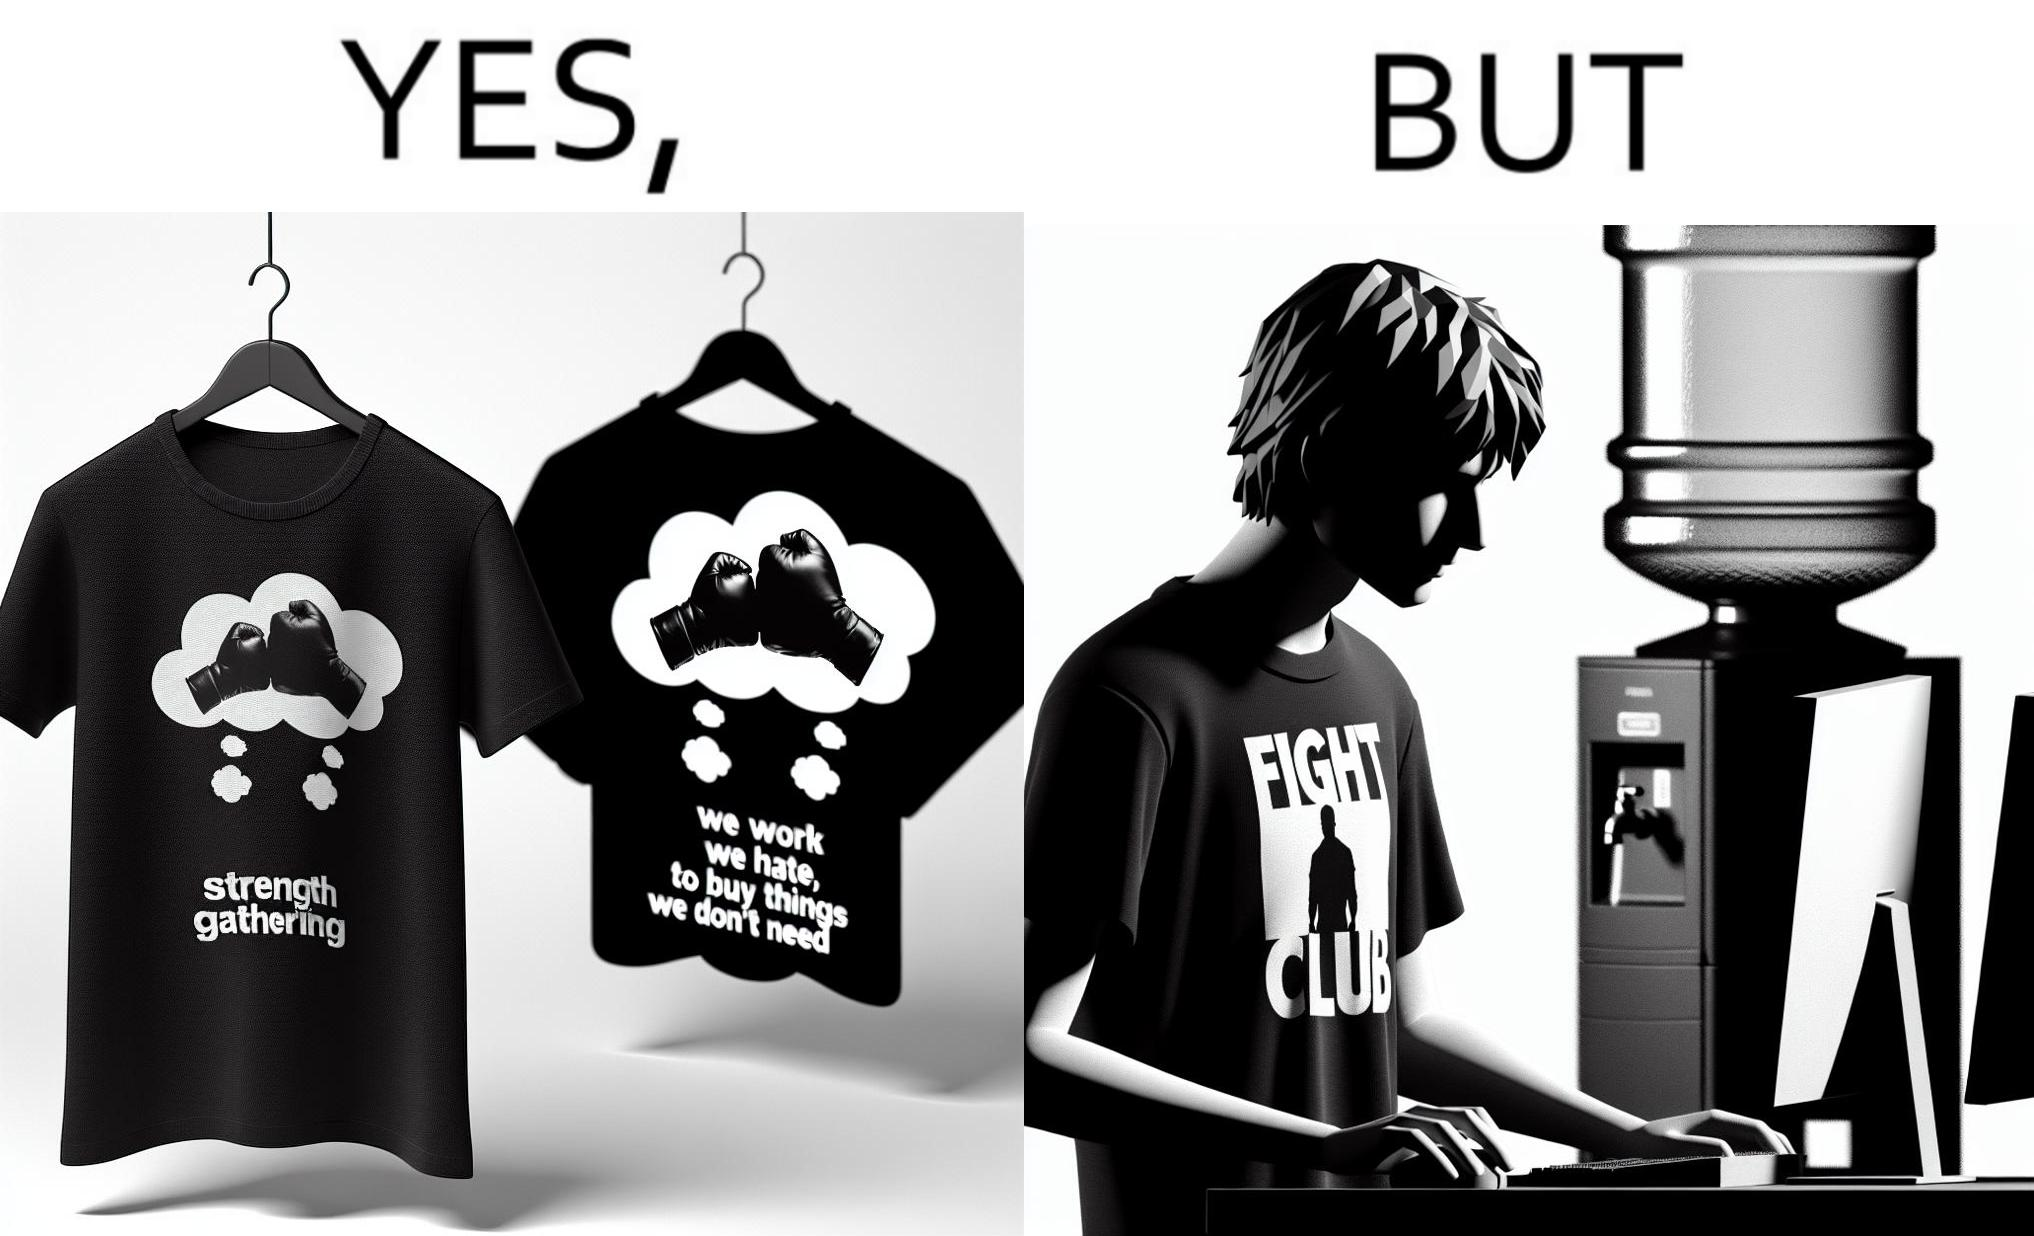Is this a satirical image? Yes, this image is satirical. 